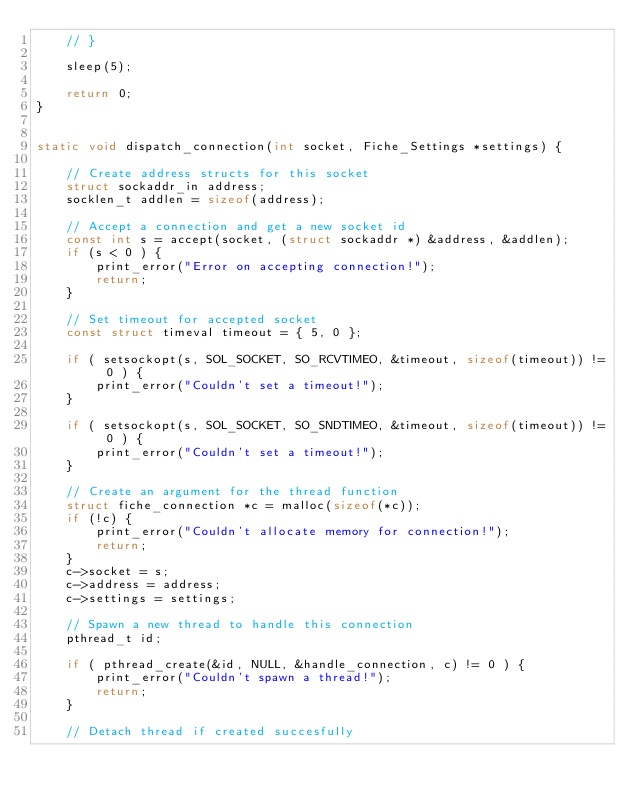<code> <loc_0><loc_0><loc_500><loc_500><_C_>    // }

    sleep(5);

    return 0;
}


static void dispatch_connection(int socket, Fiche_Settings *settings) {

    // Create address structs for this socket
    struct sockaddr_in address;
    socklen_t addlen = sizeof(address);

    // Accept a connection and get a new socket id
    const int s = accept(socket, (struct sockaddr *) &address, &addlen);
    if (s < 0 ) {
        print_error("Error on accepting connection!");
        return;
    }

    // Set timeout for accepted socket
    const struct timeval timeout = { 5, 0 };

    if ( setsockopt(s, SOL_SOCKET, SO_RCVTIMEO, &timeout, sizeof(timeout)) != 0 ) {
        print_error("Couldn't set a timeout!");
    }

    if ( setsockopt(s, SOL_SOCKET, SO_SNDTIMEO, &timeout, sizeof(timeout)) != 0 ) {
        print_error("Couldn't set a timeout!");
    }

    // Create an argument for the thread function
    struct fiche_connection *c = malloc(sizeof(*c));
    if (!c) {
        print_error("Couldn't allocate memory for connection!");
        return;
    }
    c->socket = s;
    c->address = address;
    c->settings = settings;

    // Spawn a new thread to handle this connection
    pthread_t id;

    if ( pthread_create(&id, NULL, &handle_connection, c) != 0 ) {
        print_error("Couldn't spawn a thread!");
        return;
    }

    // Detach thread if created succesfully</code> 